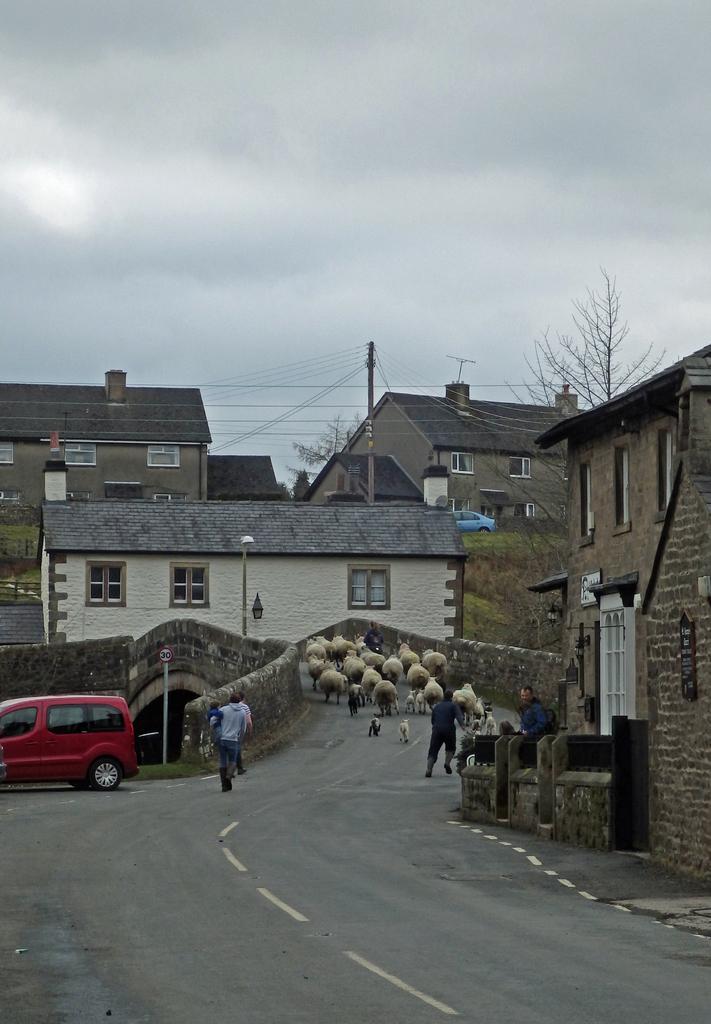Describe this image in one or two sentences. In this image we can see a few people, there is a car on the road, there are few houses, windows, poles, electric pole, wires, there is a bridge, sign board, there are sheep, also we can see trees, and the sky. 